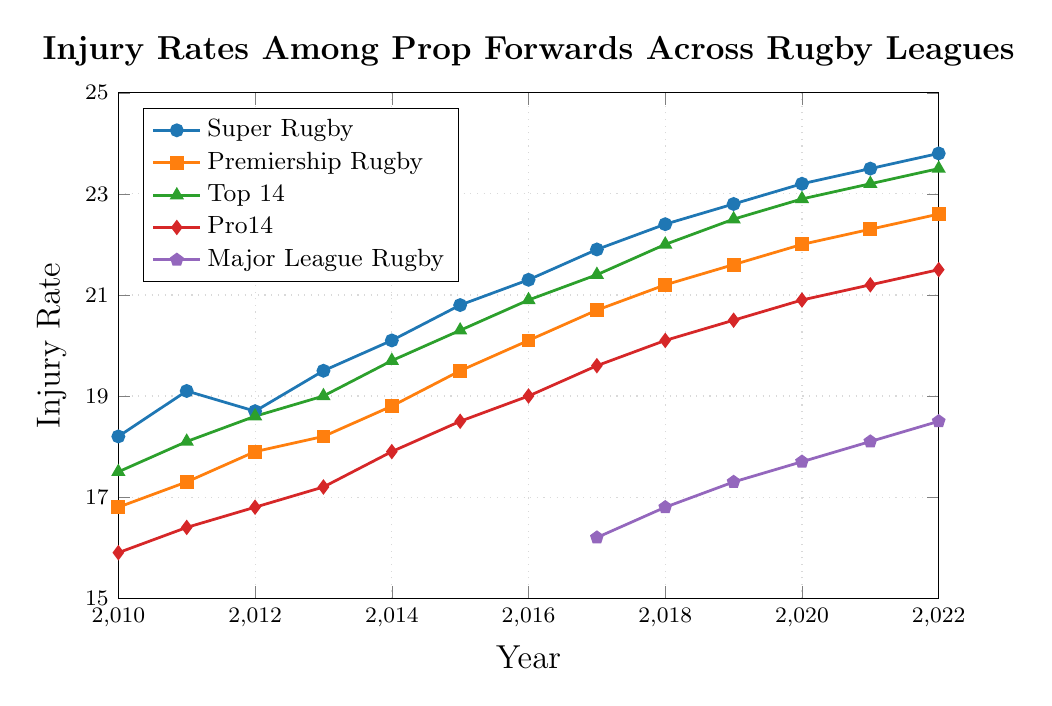What is the injury rate for Super Rugby in 2015? Find the data point for 2015 on the Super Rugby line (blue with circles). The injury rate for Super Rugby in 2015 is marked at 20.8.
Answer: 20.8 Which rugby league has the highest injury rate in 2022? Look at the data points for 2022 across all lines. Super Rugby (blue with circles) has the highest injury rate at 23.8.
Answer: Super Rugby Between which years does the Top 14 league show the most significant increase in injury rates? Identify the steepest upward trend on the Top 14 line (green with triangles). From 2010 to 2011, the increase was from 17.5 to 18.1, but the most significant jump was from 2019 to 2020 (22.5 to 22.9).
Answer: 2019-2020 What is the difference in the injury rate between Premiership Rugby and Pro14 in 2022? Find the data points for 2022 for both Premiership Rugby (orange with squares) and Pro14 (red with diamonds). The values are 22.6 (Premiership) and 21.5 (Pro14). The difference is 22.6 - 21.5 = 1.1.
Answer: 1.1 What color is used to represent Major League Rugby in the plot? The legend for Major League Rugby should be checked, and it is represented with a purple, pentagon mark.
Answer: Purple How many leagues show an increasing trend in injury rates from 2010 to 2022? Analyze the slope of each line across the entire period. Super Rugby, Premiership Rugby, Top 14, and Pro14 all show an upward trend from 2010 to 2022.
Answer: 4 Compare the injury rates for Premiership Rugby and Top 14 in 2013. Which league has a higher rate? Check the values for both leagues in 2013. Premiership Rugby is 18.2, and Top 14 is 19.0. Top 14 has a higher rate.
Answer: Top 14 What is the overall trend in injury rates observed for Pro14 from 2010 to 2022? Look at the plot for Pro14 (red with diamonds). There is a steady increase from 15.9 in 2010 to 21.5 in 2022.
Answer: Increasing What is the average injury rate for Super Rugby across the shown years? Sum the injury rates for Super Rugby from 2010 to 2022 (18.2 + 19.1 + 18.7 + 19.5 + 20.1 + 20.8 + 21.3 + 21.9 + 22.4 + 22.8 + 23.2 + 23.5 + 23.8) = 274.3. There are 13 years. Average = 274.3 / 13 ≈ 21.1.
Answer: 21.1 Which year shows the first data point for Major League Rugby, and what is the injury rate? The first point appears in 2017 for Major League Rugby (purple line with pentagons) with a rate of 16.2.
Answer: 2017, 16.2 